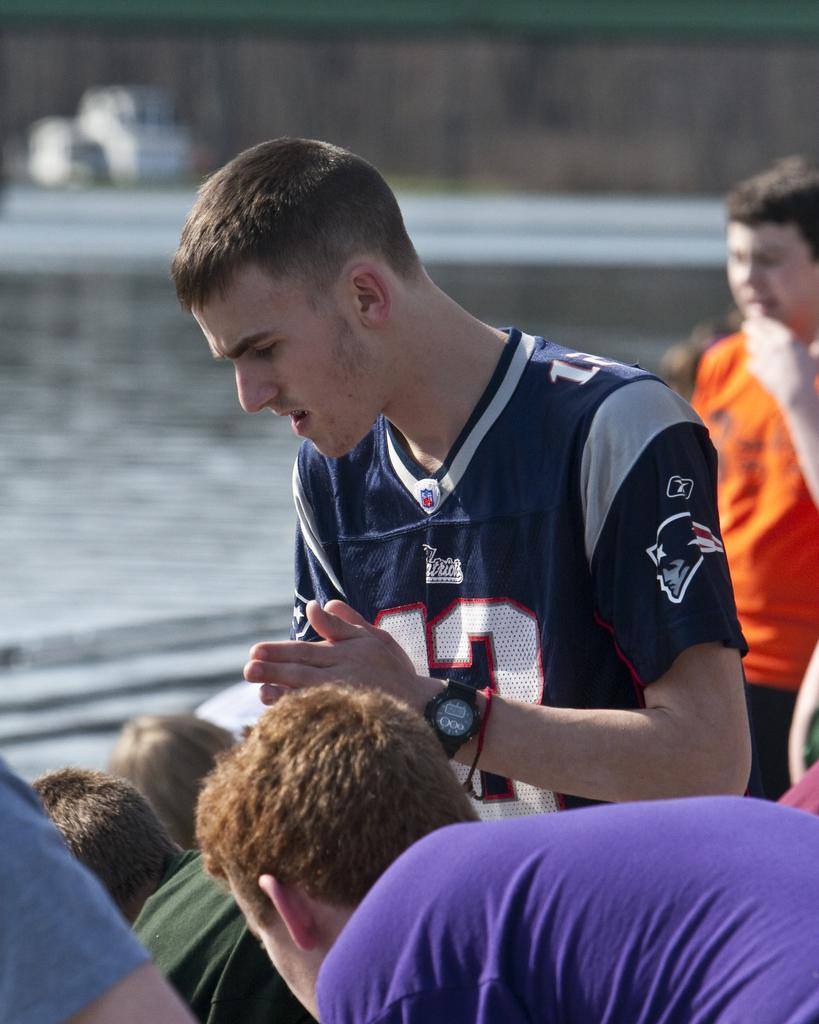<image>
Describe the image concisely. A man wearing a Patriots fan jersey looks downward. 